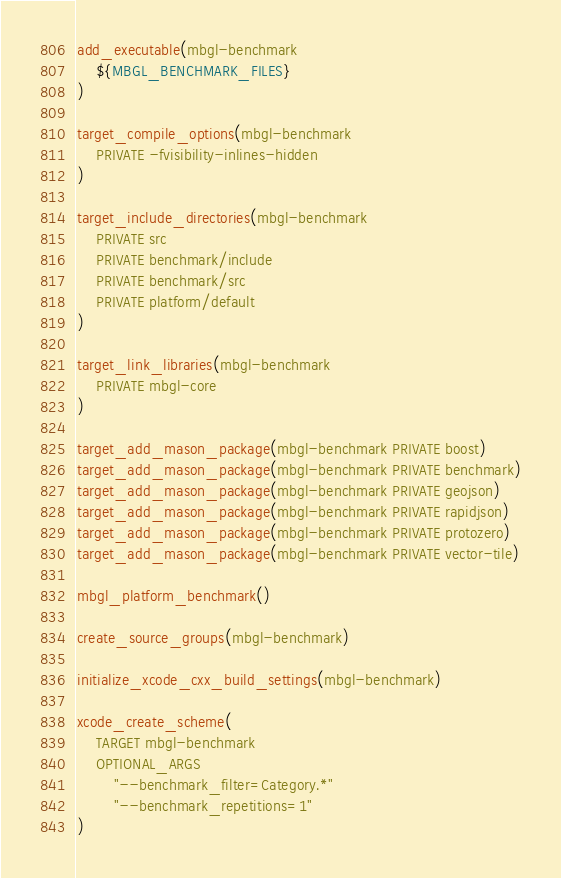<code> <loc_0><loc_0><loc_500><loc_500><_CMake_>add_executable(mbgl-benchmark
    ${MBGL_BENCHMARK_FILES}
)

target_compile_options(mbgl-benchmark
    PRIVATE -fvisibility-inlines-hidden
)

target_include_directories(mbgl-benchmark
    PRIVATE src
    PRIVATE benchmark/include
    PRIVATE benchmark/src
    PRIVATE platform/default
)

target_link_libraries(mbgl-benchmark
    PRIVATE mbgl-core
)

target_add_mason_package(mbgl-benchmark PRIVATE boost)
target_add_mason_package(mbgl-benchmark PRIVATE benchmark)
target_add_mason_package(mbgl-benchmark PRIVATE geojson)
target_add_mason_package(mbgl-benchmark PRIVATE rapidjson)
target_add_mason_package(mbgl-benchmark PRIVATE protozero)
target_add_mason_package(mbgl-benchmark PRIVATE vector-tile)

mbgl_platform_benchmark()

create_source_groups(mbgl-benchmark)

initialize_xcode_cxx_build_settings(mbgl-benchmark)

xcode_create_scheme(
    TARGET mbgl-benchmark
    OPTIONAL_ARGS
        "--benchmark_filter=Category.*"
        "--benchmark_repetitions=1"
)
</code> 